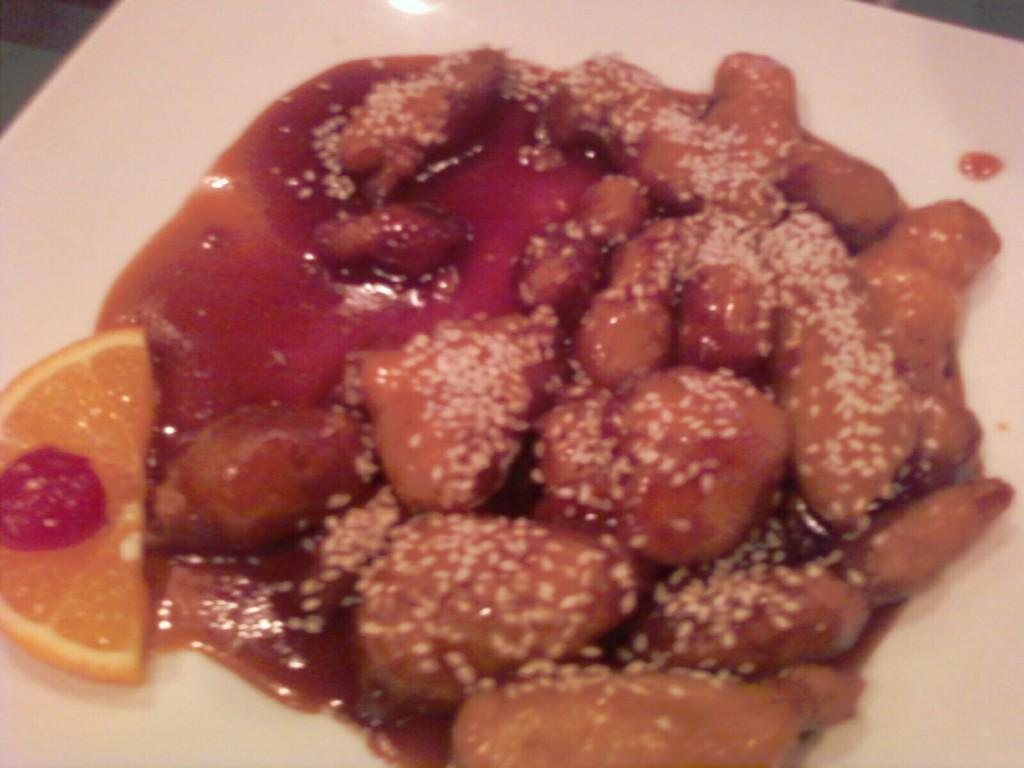What color is the plate in the image? The plate in the image is white colored. What is on the plate? There is a food item on the plate. Can you describe the colors of the food item? The food item has brown, white, red, and orange colors. How many chairs are visible in the image? There are no chairs visible in the image; it only features a plate with a food item. Can you describe the coastline in the image? There is no coastline present in the image; it only features a plate with a food item. 